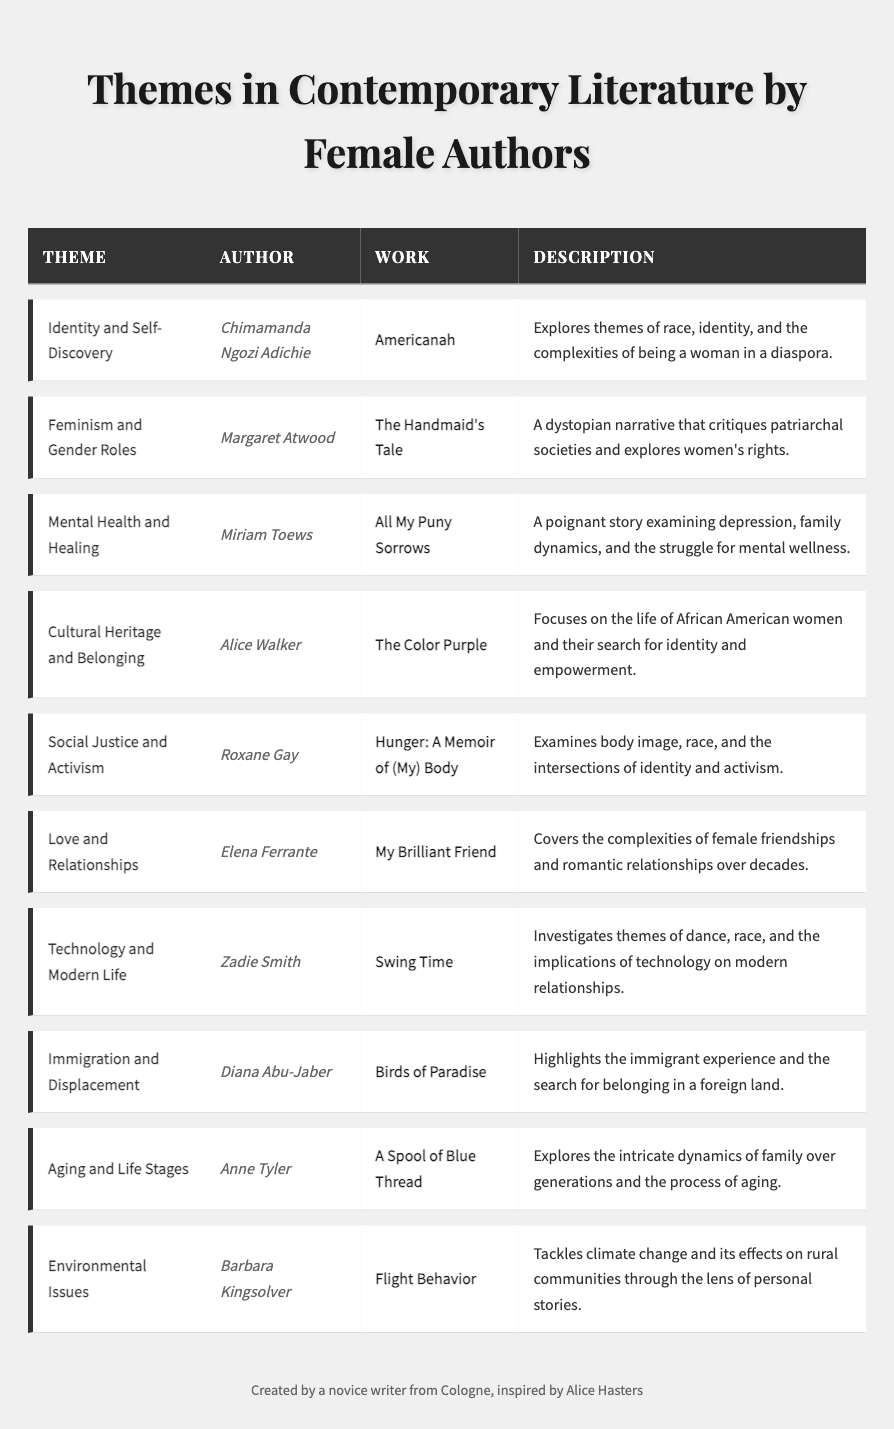What theme does 'Americanah' by Chimamanda Ngozi Adichie explore? The table lists 'Americanah' as exploring the theme of 'Identity and Self-Discovery.'
Answer: Identity and Self-Discovery Which author wrote about 'Feminism and Gender Roles'? The table shows that 'Feminism and Gender Roles' is the theme explored by Margaret Atwood in 'The Handmaid's Tale.'
Answer: Margaret Atwood What is the main focus of 'The Color Purple' by Alice Walker? According to the table, 'The Color Purple' focuses on the life of African American women and their search for identity and empowerment.
Answer: Life of African American women and search for identity Which themes are discussed in Miriam Toews' 'All My Puny Sorrows'? The table indicates that 'All My Puny Sorrows' examines 'Mental Health and Healing.'
Answer: Mental Health and Healing How many works related to 'Social Justice and Activism' are mentioned in the table? The table lists one work, 'Hunger: A Memoir of (My) Body' by Roxane Gay, under the theme of 'Social Justice and Activism.'
Answer: 1 Is 'My Brilliant Friend' associated with themes of love? Yes, the table shows that 'My Brilliant Friend' covers the complexities of female friendships and romantic relationships.
Answer: Yes Which author discusses 'Environmental Issues' and what is the title of their work? The table states that Barbara Kingsolver discusses 'Environmental Issues' in her work titled 'Flight Behavior.'
Answer: Barbara Kingsolver, 'Flight Behavior' What themes are common among the works of contemporary female authors listed in the table? Common themes include identity, feminism, mental health, love, and social justice, indicating a diverse range of contemporary issues explored in literature.
Answer: Identity, feminism, mental health, love, social justice Which two authors explore themes related to relationships? The authors Elena Ferrante and Alice Walker both explore themes related to relationships: 'My Brilliant Friend' and 'The Color Purple' respectively.
Answer: Elena Ferrante and Alice Walker Are there more works focused on personal experiences or social issues in the table? The table has a balanced presence of personal experiences like mental health and social issues like activism, making it difficult to categorize as one being more prominent.
Answer: Balanced presence 